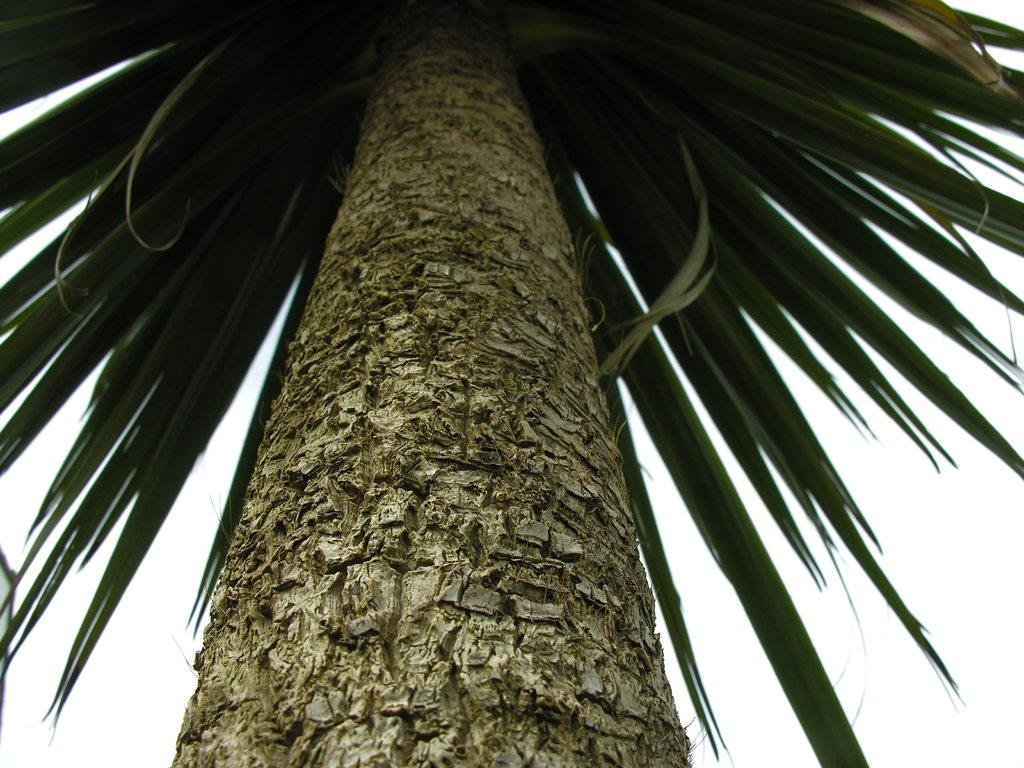What is the main subject in the center of the image? There is a tree in the center of the image. What can be seen in the background of the image? There is a sky visible in the background of the image. What is present in the sky? Clouds are present in the sky. What type of chess piece is located on top of the tree in the image? There is no chess piece present on top of the tree in the image. Is there any indication of a spy or espionage activity in the image? There is no indication of a spy or espionage activity in the image. 